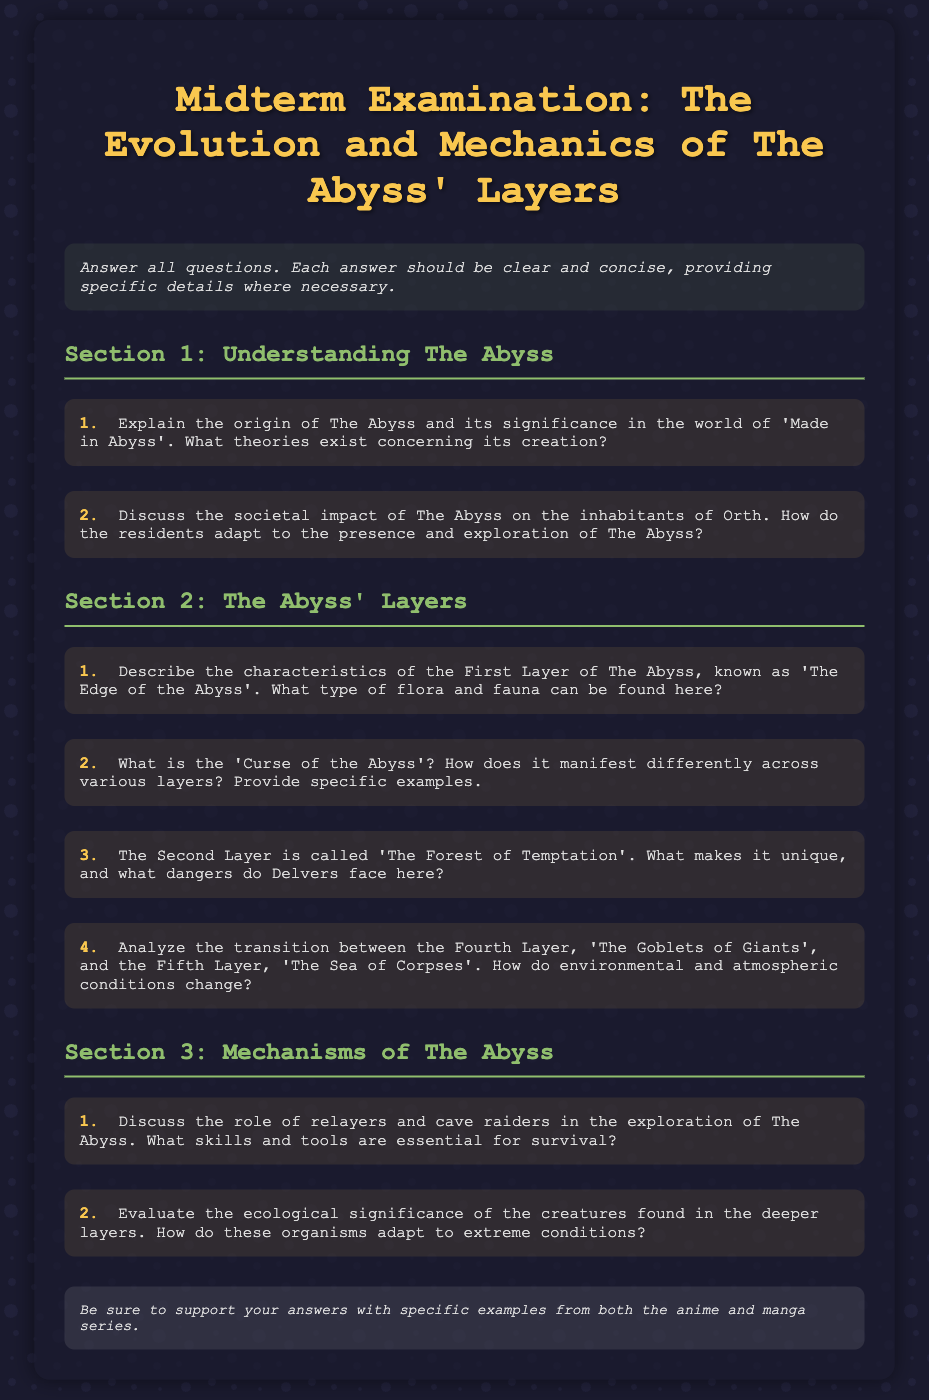What is the title of the midterm exam? The title of the midterm exam is provided in the document header.
Answer: Midterm Examination: The Evolution and Mechanics of The Abyss' Layers What is the name of the Second Layer? The document explicitly names the Second Layer within the section discussing the layers of The Abyss.
Answer: The Forest of Temptation How many sections are there in the exam? The structure of the document indicates the number of sections included in the midterm exam.
Answer: Three What is the primary focus of Section 2? The document describes Section 2 as focusing on specific aspects of The Abyss.
Answer: The Abyss' Layers What is one danger Delvers face in the Second Layer? The prompt in the document asks for dangers in the Second Layer, indicating there are specific threats to be named.
Answer: Unique dangers (specific answer might vary based on context) Which layer is referred to as 'The Goblets of Giants'? The document directly describes the Fourth Layer with this name.
Answer: The Fourth Layer What is the Curse of the Abyss? The document mentions this term which is key to understanding the impact of The Abyss on Delvers.
Answer: A significant phenomenon affecting explorers What role do relayers play in The Abyss? The question highlights the function of relayers as mentioned in Section 3 regarding exploration.
Answer: Exploration assistance How should answers be supported? The document clearly states the requirement for supporting answers in a specific way.
Answer: Specific examples from both the anime and manga series 